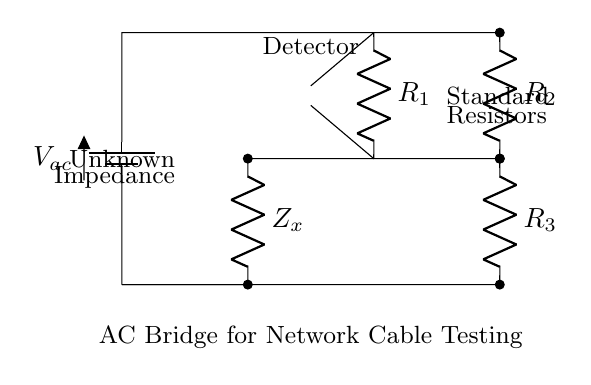What type of circuit is this? This is an AC bridge circuit, specifically designed for measuring impedance. The layout and components are characteristic of bridge circuits utilized in comparison measurements.
Answer: AC bridge What is the function of the detector? The detector in this circuit is used to measure the balance condition of the bridge, indicating when the voltages across its terminals are equal, which means the impedances are balanced.
Answer: Measure balance What is the unknown component labeled in the circuit? The unknown component is labeled as Z_x, which represents the impedance being measured. It is essential for determining the characteristics of the network cable.
Answer: Unknown Impedance What type of voltage source is present in the circuit? The voltage source is specified as V_ac, indicating it supplies alternating current (AC) to the bridge circuit for the impedance measurement.
Answer: Alternating current How many resistors are used in this bridge? There are three resistors labeled R_1, R_2, and R_3 present in the circuit, used to balance the bridge and accurately measure the unknown impedance.
Answer: Three resistors What does the label "Standard Resistors" imply? The label indicates that R_1, R_2, and R_3 are known, reference resistors with specified values used for comparison against the unknown impedance to ensure accurate measurement.
Answer: Known reference What is the purpose of the connections marked with "*-*"? The "*-*" notation signifies that the components, in this case, R_2 and Z_x, are part of a parallel configuration with respect to the bridge circuit, necessary for its functioning.
Answer: Parallel configuration 